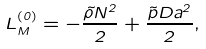<formula> <loc_0><loc_0><loc_500><loc_500>L ^ { ( 0 ) } _ { M } = - \frac { \tilde { \rho } N ^ { 2 } } { 2 } + \frac { { \tilde { p } } D a ^ { 2 } } { 2 } ,</formula> 